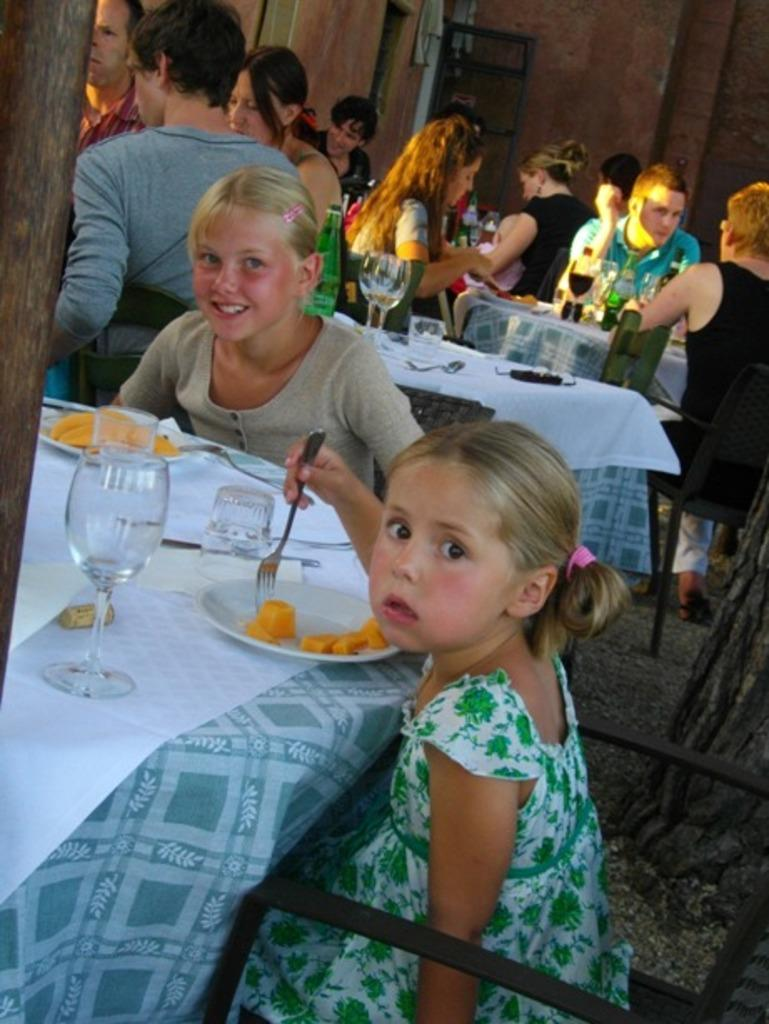What is happening in the image involving the group of persons? The persons in the image are sitting on chairs and having their food. Can you describe the composition of the group? There are two kids in the image, and they are also having their food. How are the kids eating their food? The kids are using forks to eat. What type of glass is being used by the owner in the image? There is no glass or owner present in the image. Is the prison mentioned or depicted in the image? No, the image does not involve a prison or any prison-related elements. 